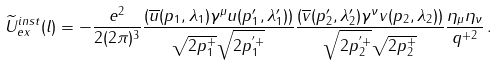Convert formula to latex. <formula><loc_0><loc_0><loc_500><loc_500>\widetilde { U } _ { e x } ^ { i n s t } ( l ) = - \frac { e ^ { 2 } } { 2 ( 2 \pi ) ^ { 3 } } \frac { ( \overline { u } ( p _ { 1 } , \lambda _ { 1 } ) \gamma ^ { \mu } u ( p ^ { \prime } _ { 1 } , \lambda ^ { \prime } _ { 1 } ) ) } { \sqrt { 2 p _ { 1 } ^ { + } } \sqrt { 2 p _ { 1 } ^ { ^ { \prime } + } } } \frac { ( \overline { v } ( p ^ { \prime } _ { 2 } , \lambda ^ { \prime } _ { 2 } ) \gamma ^ { \nu } v ( p _ { 2 } , \lambda _ { 2 } ) ) } { \sqrt { 2 p _ { 2 } ^ { ^ { \prime } + } } \sqrt { 2 p _ { 2 } ^ { + } } } \frac { \eta _ { \mu } \eta _ { \nu } } { q ^ { + 2 } } \, .</formula> 